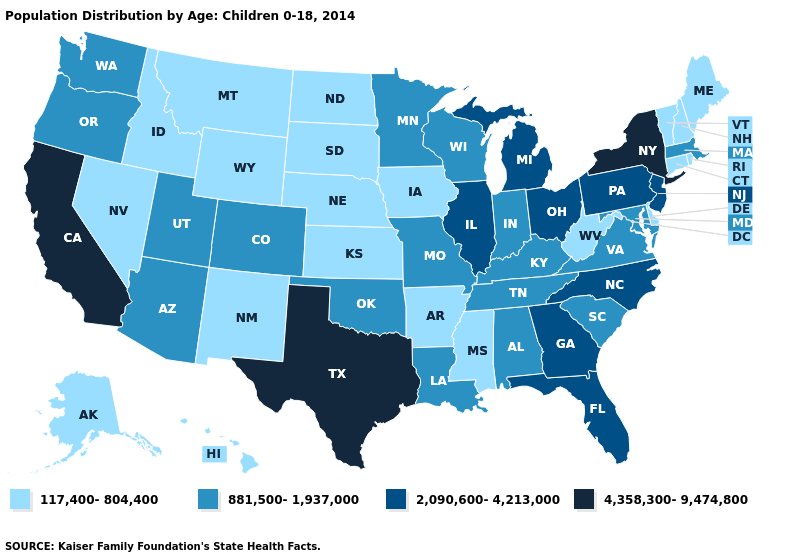Name the states that have a value in the range 2,090,600-4,213,000?
Quick response, please. Florida, Georgia, Illinois, Michigan, New Jersey, North Carolina, Ohio, Pennsylvania. Name the states that have a value in the range 117,400-804,400?
Concise answer only. Alaska, Arkansas, Connecticut, Delaware, Hawaii, Idaho, Iowa, Kansas, Maine, Mississippi, Montana, Nebraska, Nevada, New Hampshire, New Mexico, North Dakota, Rhode Island, South Dakota, Vermont, West Virginia, Wyoming. Does Indiana have a lower value than Tennessee?
Short answer required. No. Name the states that have a value in the range 4,358,300-9,474,800?
Give a very brief answer. California, New York, Texas. Name the states that have a value in the range 2,090,600-4,213,000?
Quick response, please. Florida, Georgia, Illinois, Michigan, New Jersey, North Carolina, Ohio, Pennsylvania. Name the states that have a value in the range 2,090,600-4,213,000?
Give a very brief answer. Florida, Georgia, Illinois, Michigan, New Jersey, North Carolina, Ohio, Pennsylvania. What is the highest value in states that border North Dakota?
Write a very short answer. 881,500-1,937,000. What is the value of South Carolina?
Quick response, please. 881,500-1,937,000. Which states have the lowest value in the USA?
Give a very brief answer. Alaska, Arkansas, Connecticut, Delaware, Hawaii, Idaho, Iowa, Kansas, Maine, Mississippi, Montana, Nebraska, Nevada, New Hampshire, New Mexico, North Dakota, Rhode Island, South Dakota, Vermont, West Virginia, Wyoming. Does the map have missing data?
Write a very short answer. No. Name the states that have a value in the range 4,358,300-9,474,800?
Give a very brief answer. California, New York, Texas. Name the states that have a value in the range 881,500-1,937,000?
Be succinct. Alabama, Arizona, Colorado, Indiana, Kentucky, Louisiana, Maryland, Massachusetts, Minnesota, Missouri, Oklahoma, Oregon, South Carolina, Tennessee, Utah, Virginia, Washington, Wisconsin. Does Hawaii have the highest value in the West?
Concise answer only. No. Name the states that have a value in the range 2,090,600-4,213,000?
Concise answer only. Florida, Georgia, Illinois, Michigan, New Jersey, North Carolina, Ohio, Pennsylvania. Among the states that border Wyoming , which have the lowest value?
Quick response, please. Idaho, Montana, Nebraska, South Dakota. 